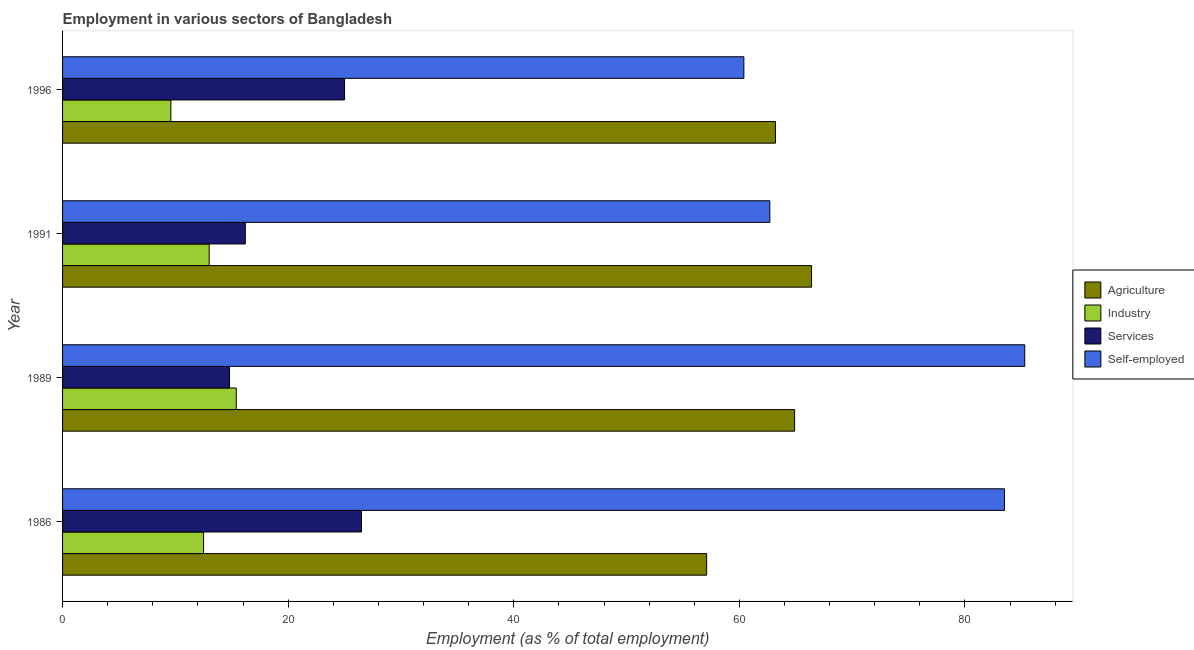How many groups of bars are there?
Provide a succinct answer. 4. Across all years, what is the maximum percentage of workers in industry?
Your answer should be compact. 15.4. Across all years, what is the minimum percentage of workers in services?
Offer a very short reply. 14.8. What is the total percentage of workers in agriculture in the graph?
Keep it short and to the point. 251.6. What is the difference between the percentage of workers in industry in 1989 and the percentage of workers in services in 1991?
Keep it short and to the point. -0.8. What is the average percentage of workers in industry per year?
Your answer should be compact. 12.62. In the year 1989, what is the difference between the percentage of workers in agriculture and percentage of self employed workers?
Make the answer very short. -20.4. What is the ratio of the percentage of workers in industry in 1989 to that in 1996?
Provide a succinct answer. 1.6. Is the difference between the percentage of self employed workers in 1986 and 1989 greater than the difference between the percentage of workers in agriculture in 1986 and 1989?
Offer a very short reply. Yes. What is the difference between the highest and the second highest percentage of workers in agriculture?
Your response must be concise. 1.5. What is the difference between the highest and the lowest percentage of self employed workers?
Provide a short and direct response. 24.9. Is the sum of the percentage of workers in services in 1986 and 1989 greater than the maximum percentage of workers in industry across all years?
Keep it short and to the point. Yes. Is it the case that in every year, the sum of the percentage of self employed workers and percentage of workers in agriculture is greater than the sum of percentage of workers in services and percentage of workers in industry?
Provide a short and direct response. Yes. What does the 1st bar from the top in 1989 represents?
Provide a short and direct response. Self-employed. What does the 4th bar from the bottom in 1989 represents?
Your answer should be very brief. Self-employed. How many bars are there?
Keep it short and to the point. 16. Are all the bars in the graph horizontal?
Provide a short and direct response. Yes. How many years are there in the graph?
Your answer should be compact. 4. Does the graph contain any zero values?
Ensure brevity in your answer.  No. Where does the legend appear in the graph?
Your answer should be very brief. Center right. How many legend labels are there?
Your answer should be very brief. 4. How are the legend labels stacked?
Offer a very short reply. Vertical. What is the title of the graph?
Provide a succinct answer. Employment in various sectors of Bangladesh. Does "Payroll services" appear as one of the legend labels in the graph?
Your response must be concise. No. What is the label or title of the X-axis?
Your response must be concise. Employment (as % of total employment). What is the label or title of the Y-axis?
Ensure brevity in your answer.  Year. What is the Employment (as % of total employment) in Agriculture in 1986?
Ensure brevity in your answer.  57.1. What is the Employment (as % of total employment) in Industry in 1986?
Offer a terse response. 12.5. What is the Employment (as % of total employment) of Services in 1986?
Provide a short and direct response. 26.5. What is the Employment (as % of total employment) in Self-employed in 1986?
Offer a terse response. 83.5. What is the Employment (as % of total employment) of Agriculture in 1989?
Offer a very short reply. 64.9. What is the Employment (as % of total employment) of Industry in 1989?
Make the answer very short. 15.4. What is the Employment (as % of total employment) in Services in 1989?
Offer a terse response. 14.8. What is the Employment (as % of total employment) of Self-employed in 1989?
Offer a very short reply. 85.3. What is the Employment (as % of total employment) of Agriculture in 1991?
Give a very brief answer. 66.4. What is the Employment (as % of total employment) of Industry in 1991?
Provide a succinct answer. 13. What is the Employment (as % of total employment) in Services in 1991?
Keep it short and to the point. 16.2. What is the Employment (as % of total employment) in Self-employed in 1991?
Your answer should be compact. 62.7. What is the Employment (as % of total employment) in Agriculture in 1996?
Ensure brevity in your answer.  63.2. What is the Employment (as % of total employment) in Industry in 1996?
Provide a succinct answer. 9.6. What is the Employment (as % of total employment) in Services in 1996?
Your response must be concise. 25. What is the Employment (as % of total employment) of Self-employed in 1996?
Ensure brevity in your answer.  60.4. Across all years, what is the maximum Employment (as % of total employment) in Agriculture?
Make the answer very short. 66.4. Across all years, what is the maximum Employment (as % of total employment) in Industry?
Your answer should be compact. 15.4. Across all years, what is the maximum Employment (as % of total employment) of Services?
Your answer should be compact. 26.5. Across all years, what is the maximum Employment (as % of total employment) in Self-employed?
Make the answer very short. 85.3. Across all years, what is the minimum Employment (as % of total employment) of Agriculture?
Keep it short and to the point. 57.1. Across all years, what is the minimum Employment (as % of total employment) in Industry?
Give a very brief answer. 9.6. Across all years, what is the minimum Employment (as % of total employment) in Services?
Your response must be concise. 14.8. Across all years, what is the minimum Employment (as % of total employment) in Self-employed?
Ensure brevity in your answer.  60.4. What is the total Employment (as % of total employment) of Agriculture in the graph?
Give a very brief answer. 251.6. What is the total Employment (as % of total employment) of Industry in the graph?
Keep it short and to the point. 50.5. What is the total Employment (as % of total employment) of Services in the graph?
Provide a short and direct response. 82.5. What is the total Employment (as % of total employment) in Self-employed in the graph?
Provide a short and direct response. 291.9. What is the difference between the Employment (as % of total employment) in Agriculture in 1986 and that in 1989?
Make the answer very short. -7.8. What is the difference between the Employment (as % of total employment) in Industry in 1986 and that in 1989?
Your answer should be compact. -2.9. What is the difference between the Employment (as % of total employment) in Self-employed in 1986 and that in 1989?
Your answer should be very brief. -1.8. What is the difference between the Employment (as % of total employment) of Services in 1986 and that in 1991?
Your response must be concise. 10.3. What is the difference between the Employment (as % of total employment) of Self-employed in 1986 and that in 1991?
Provide a succinct answer. 20.8. What is the difference between the Employment (as % of total employment) in Agriculture in 1986 and that in 1996?
Offer a terse response. -6.1. What is the difference between the Employment (as % of total employment) of Self-employed in 1986 and that in 1996?
Give a very brief answer. 23.1. What is the difference between the Employment (as % of total employment) in Industry in 1989 and that in 1991?
Your answer should be very brief. 2.4. What is the difference between the Employment (as % of total employment) in Self-employed in 1989 and that in 1991?
Give a very brief answer. 22.6. What is the difference between the Employment (as % of total employment) of Self-employed in 1989 and that in 1996?
Provide a short and direct response. 24.9. What is the difference between the Employment (as % of total employment) in Agriculture in 1991 and that in 1996?
Your answer should be compact. 3.2. What is the difference between the Employment (as % of total employment) of Industry in 1991 and that in 1996?
Your answer should be compact. 3.4. What is the difference between the Employment (as % of total employment) of Agriculture in 1986 and the Employment (as % of total employment) of Industry in 1989?
Your answer should be compact. 41.7. What is the difference between the Employment (as % of total employment) in Agriculture in 1986 and the Employment (as % of total employment) in Services in 1989?
Provide a succinct answer. 42.3. What is the difference between the Employment (as % of total employment) of Agriculture in 1986 and the Employment (as % of total employment) of Self-employed in 1989?
Provide a short and direct response. -28.2. What is the difference between the Employment (as % of total employment) in Industry in 1986 and the Employment (as % of total employment) in Self-employed in 1989?
Your answer should be compact. -72.8. What is the difference between the Employment (as % of total employment) in Services in 1986 and the Employment (as % of total employment) in Self-employed in 1989?
Offer a very short reply. -58.8. What is the difference between the Employment (as % of total employment) of Agriculture in 1986 and the Employment (as % of total employment) of Industry in 1991?
Provide a short and direct response. 44.1. What is the difference between the Employment (as % of total employment) in Agriculture in 1986 and the Employment (as % of total employment) in Services in 1991?
Provide a succinct answer. 40.9. What is the difference between the Employment (as % of total employment) of Industry in 1986 and the Employment (as % of total employment) of Self-employed in 1991?
Make the answer very short. -50.2. What is the difference between the Employment (as % of total employment) of Services in 1986 and the Employment (as % of total employment) of Self-employed in 1991?
Offer a very short reply. -36.2. What is the difference between the Employment (as % of total employment) of Agriculture in 1986 and the Employment (as % of total employment) of Industry in 1996?
Your answer should be very brief. 47.5. What is the difference between the Employment (as % of total employment) of Agriculture in 1986 and the Employment (as % of total employment) of Services in 1996?
Your response must be concise. 32.1. What is the difference between the Employment (as % of total employment) of Industry in 1986 and the Employment (as % of total employment) of Self-employed in 1996?
Your response must be concise. -47.9. What is the difference between the Employment (as % of total employment) in Services in 1986 and the Employment (as % of total employment) in Self-employed in 1996?
Keep it short and to the point. -33.9. What is the difference between the Employment (as % of total employment) of Agriculture in 1989 and the Employment (as % of total employment) of Industry in 1991?
Provide a short and direct response. 51.9. What is the difference between the Employment (as % of total employment) in Agriculture in 1989 and the Employment (as % of total employment) in Services in 1991?
Offer a very short reply. 48.7. What is the difference between the Employment (as % of total employment) of Industry in 1989 and the Employment (as % of total employment) of Services in 1991?
Ensure brevity in your answer.  -0.8. What is the difference between the Employment (as % of total employment) of Industry in 1989 and the Employment (as % of total employment) of Self-employed in 1991?
Give a very brief answer. -47.3. What is the difference between the Employment (as % of total employment) of Services in 1989 and the Employment (as % of total employment) of Self-employed in 1991?
Keep it short and to the point. -47.9. What is the difference between the Employment (as % of total employment) in Agriculture in 1989 and the Employment (as % of total employment) in Industry in 1996?
Provide a short and direct response. 55.3. What is the difference between the Employment (as % of total employment) of Agriculture in 1989 and the Employment (as % of total employment) of Services in 1996?
Provide a short and direct response. 39.9. What is the difference between the Employment (as % of total employment) in Industry in 1989 and the Employment (as % of total employment) in Services in 1996?
Your response must be concise. -9.6. What is the difference between the Employment (as % of total employment) of Industry in 1989 and the Employment (as % of total employment) of Self-employed in 1996?
Your answer should be compact. -45. What is the difference between the Employment (as % of total employment) of Services in 1989 and the Employment (as % of total employment) of Self-employed in 1996?
Ensure brevity in your answer.  -45.6. What is the difference between the Employment (as % of total employment) of Agriculture in 1991 and the Employment (as % of total employment) of Industry in 1996?
Offer a very short reply. 56.8. What is the difference between the Employment (as % of total employment) of Agriculture in 1991 and the Employment (as % of total employment) of Services in 1996?
Your answer should be compact. 41.4. What is the difference between the Employment (as % of total employment) in Agriculture in 1991 and the Employment (as % of total employment) in Self-employed in 1996?
Provide a short and direct response. 6. What is the difference between the Employment (as % of total employment) in Industry in 1991 and the Employment (as % of total employment) in Self-employed in 1996?
Your response must be concise. -47.4. What is the difference between the Employment (as % of total employment) of Services in 1991 and the Employment (as % of total employment) of Self-employed in 1996?
Give a very brief answer. -44.2. What is the average Employment (as % of total employment) in Agriculture per year?
Offer a terse response. 62.9. What is the average Employment (as % of total employment) of Industry per year?
Give a very brief answer. 12.62. What is the average Employment (as % of total employment) of Services per year?
Offer a terse response. 20.62. What is the average Employment (as % of total employment) of Self-employed per year?
Ensure brevity in your answer.  72.97. In the year 1986, what is the difference between the Employment (as % of total employment) in Agriculture and Employment (as % of total employment) in Industry?
Your answer should be compact. 44.6. In the year 1986, what is the difference between the Employment (as % of total employment) in Agriculture and Employment (as % of total employment) in Services?
Keep it short and to the point. 30.6. In the year 1986, what is the difference between the Employment (as % of total employment) in Agriculture and Employment (as % of total employment) in Self-employed?
Your answer should be very brief. -26.4. In the year 1986, what is the difference between the Employment (as % of total employment) in Industry and Employment (as % of total employment) in Services?
Keep it short and to the point. -14. In the year 1986, what is the difference between the Employment (as % of total employment) of Industry and Employment (as % of total employment) of Self-employed?
Give a very brief answer. -71. In the year 1986, what is the difference between the Employment (as % of total employment) of Services and Employment (as % of total employment) of Self-employed?
Ensure brevity in your answer.  -57. In the year 1989, what is the difference between the Employment (as % of total employment) in Agriculture and Employment (as % of total employment) in Industry?
Provide a succinct answer. 49.5. In the year 1989, what is the difference between the Employment (as % of total employment) in Agriculture and Employment (as % of total employment) in Services?
Your answer should be very brief. 50.1. In the year 1989, what is the difference between the Employment (as % of total employment) in Agriculture and Employment (as % of total employment) in Self-employed?
Ensure brevity in your answer.  -20.4. In the year 1989, what is the difference between the Employment (as % of total employment) in Industry and Employment (as % of total employment) in Services?
Your answer should be compact. 0.6. In the year 1989, what is the difference between the Employment (as % of total employment) in Industry and Employment (as % of total employment) in Self-employed?
Make the answer very short. -69.9. In the year 1989, what is the difference between the Employment (as % of total employment) of Services and Employment (as % of total employment) of Self-employed?
Your response must be concise. -70.5. In the year 1991, what is the difference between the Employment (as % of total employment) in Agriculture and Employment (as % of total employment) in Industry?
Your answer should be very brief. 53.4. In the year 1991, what is the difference between the Employment (as % of total employment) of Agriculture and Employment (as % of total employment) of Services?
Provide a succinct answer. 50.2. In the year 1991, what is the difference between the Employment (as % of total employment) in Industry and Employment (as % of total employment) in Services?
Your answer should be compact. -3.2. In the year 1991, what is the difference between the Employment (as % of total employment) in Industry and Employment (as % of total employment) in Self-employed?
Keep it short and to the point. -49.7. In the year 1991, what is the difference between the Employment (as % of total employment) in Services and Employment (as % of total employment) in Self-employed?
Offer a very short reply. -46.5. In the year 1996, what is the difference between the Employment (as % of total employment) in Agriculture and Employment (as % of total employment) in Industry?
Offer a terse response. 53.6. In the year 1996, what is the difference between the Employment (as % of total employment) of Agriculture and Employment (as % of total employment) of Services?
Ensure brevity in your answer.  38.2. In the year 1996, what is the difference between the Employment (as % of total employment) in Agriculture and Employment (as % of total employment) in Self-employed?
Provide a short and direct response. 2.8. In the year 1996, what is the difference between the Employment (as % of total employment) in Industry and Employment (as % of total employment) in Services?
Your response must be concise. -15.4. In the year 1996, what is the difference between the Employment (as % of total employment) of Industry and Employment (as % of total employment) of Self-employed?
Offer a very short reply. -50.8. In the year 1996, what is the difference between the Employment (as % of total employment) of Services and Employment (as % of total employment) of Self-employed?
Provide a short and direct response. -35.4. What is the ratio of the Employment (as % of total employment) of Agriculture in 1986 to that in 1989?
Offer a terse response. 0.88. What is the ratio of the Employment (as % of total employment) of Industry in 1986 to that in 1989?
Your answer should be compact. 0.81. What is the ratio of the Employment (as % of total employment) in Services in 1986 to that in 1989?
Provide a short and direct response. 1.79. What is the ratio of the Employment (as % of total employment) in Self-employed in 1986 to that in 1989?
Your response must be concise. 0.98. What is the ratio of the Employment (as % of total employment) of Agriculture in 1986 to that in 1991?
Provide a short and direct response. 0.86. What is the ratio of the Employment (as % of total employment) of Industry in 1986 to that in 1991?
Your answer should be compact. 0.96. What is the ratio of the Employment (as % of total employment) in Services in 1986 to that in 1991?
Provide a short and direct response. 1.64. What is the ratio of the Employment (as % of total employment) in Self-employed in 1986 to that in 1991?
Your answer should be compact. 1.33. What is the ratio of the Employment (as % of total employment) in Agriculture in 1986 to that in 1996?
Keep it short and to the point. 0.9. What is the ratio of the Employment (as % of total employment) in Industry in 1986 to that in 1996?
Provide a succinct answer. 1.3. What is the ratio of the Employment (as % of total employment) of Services in 1986 to that in 1996?
Make the answer very short. 1.06. What is the ratio of the Employment (as % of total employment) in Self-employed in 1986 to that in 1996?
Offer a very short reply. 1.38. What is the ratio of the Employment (as % of total employment) of Agriculture in 1989 to that in 1991?
Offer a terse response. 0.98. What is the ratio of the Employment (as % of total employment) of Industry in 1989 to that in 1991?
Ensure brevity in your answer.  1.18. What is the ratio of the Employment (as % of total employment) of Services in 1989 to that in 1991?
Your response must be concise. 0.91. What is the ratio of the Employment (as % of total employment) of Self-employed in 1989 to that in 1991?
Provide a short and direct response. 1.36. What is the ratio of the Employment (as % of total employment) of Agriculture in 1989 to that in 1996?
Give a very brief answer. 1.03. What is the ratio of the Employment (as % of total employment) in Industry in 1989 to that in 1996?
Provide a succinct answer. 1.6. What is the ratio of the Employment (as % of total employment) in Services in 1989 to that in 1996?
Your response must be concise. 0.59. What is the ratio of the Employment (as % of total employment) of Self-employed in 1989 to that in 1996?
Offer a very short reply. 1.41. What is the ratio of the Employment (as % of total employment) in Agriculture in 1991 to that in 1996?
Your answer should be very brief. 1.05. What is the ratio of the Employment (as % of total employment) in Industry in 1991 to that in 1996?
Make the answer very short. 1.35. What is the ratio of the Employment (as % of total employment) in Services in 1991 to that in 1996?
Give a very brief answer. 0.65. What is the ratio of the Employment (as % of total employment) of Self-employed in 1991 to that in 1996?
Offer a very short reply. 1.04. What is the difference between the highest and the second highest Employment (as % of total employment) in Agriculture?
Keep it short and to the point. 1.5. What is the difference between the highest and the lowest Employment (as % of total employment) in Self-employed?
Provide a succinct answer. 24.9. 